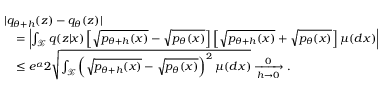<formula> <loc_0><loc_0><loc_500><loc_500>\begin{array} { r l } & { | q _ { \theta + h } ( z ) - q _ { \theta } ( z ) | } \\ & { \quad = \left | \int _ { \mathcal { X } } q ( z | x ) \left [ \sqrt { p _ { \theta + h } ( x ) } - \sqrt { p _ { \theta } ( x ) } \right ] \left [ \sqrt { p _ { \theta + h } ( x ) } + \sqrt { p _ { \theta } ( x ) } \right ] \mu ( d x ) \right | } \\ & { \quad \leq e ^ { \alpha } 2 \sqrt { \int _ { \mathcal { X } } \left ( \sqrt { p _ { \theta + h } ( x ) } - \sqrt { p _ { \theta } ( x ) } \right ) ^ { 2 } \mu ( d x ) } \xrightarrow [ h \to 0 ] 0 . } \end{array}</formula> 